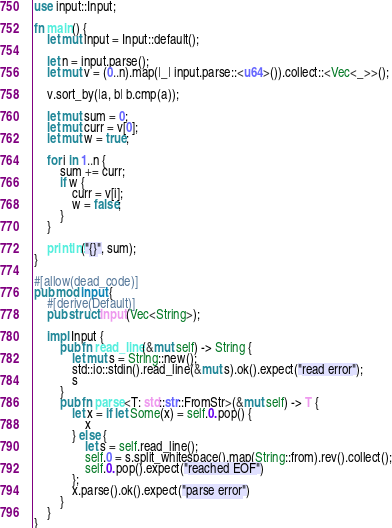<code> <loc_0><loc_0><loc_500><loc_500><_Rust_>use input::Input;

fn main() {
    let mut input = Input::default();

    let n = input.parse();
    let mut v = (0..n).map(|_| input.parse::<u64>()).collect::<Vec<_>>();

    v.sort_by(|a, b| b.cmp(a));

    let mut sum = 0;
    let mut curr = v[0];
    let mut w = true;

    for i in 1..n {
        sum += curr;
        if w {
            curr = v[i];
            w = false;
        }
    }

    println!("{}", sum);
}

#[allow(dead_code)]
pub mod input {
    #[derive(Default)]
    pub struct Input(Vec<String>);

    impl Input {
        pub fn read_line(&mut self) -> String {
            let mut s = String::new();
            std::io::stdin().read_line(&mut s).ok().expect("read error");
            s
        }
        pub fn parse<T: std::str::FromStr>(&mut self) -> T {
            let x = if let Some(x) = self.0.pop() {
                x
            } else {
                let s = self.read_line();
                self.0 = s.split_whitespace().map(String::from).rev().collect();
                self.0.pop().expect("reached EOF")
            };
            x.parse().ok().expect("parse error")
        }
    }
}
</code> 